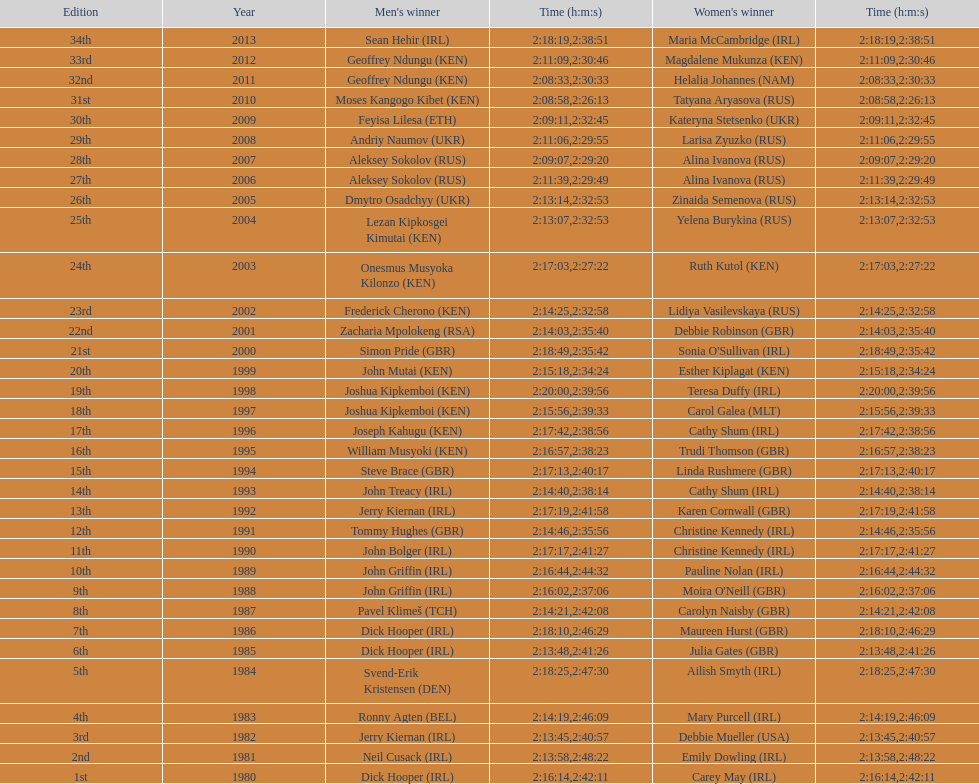In 2009, who completed the race more quickly - the male or the female? Male. 